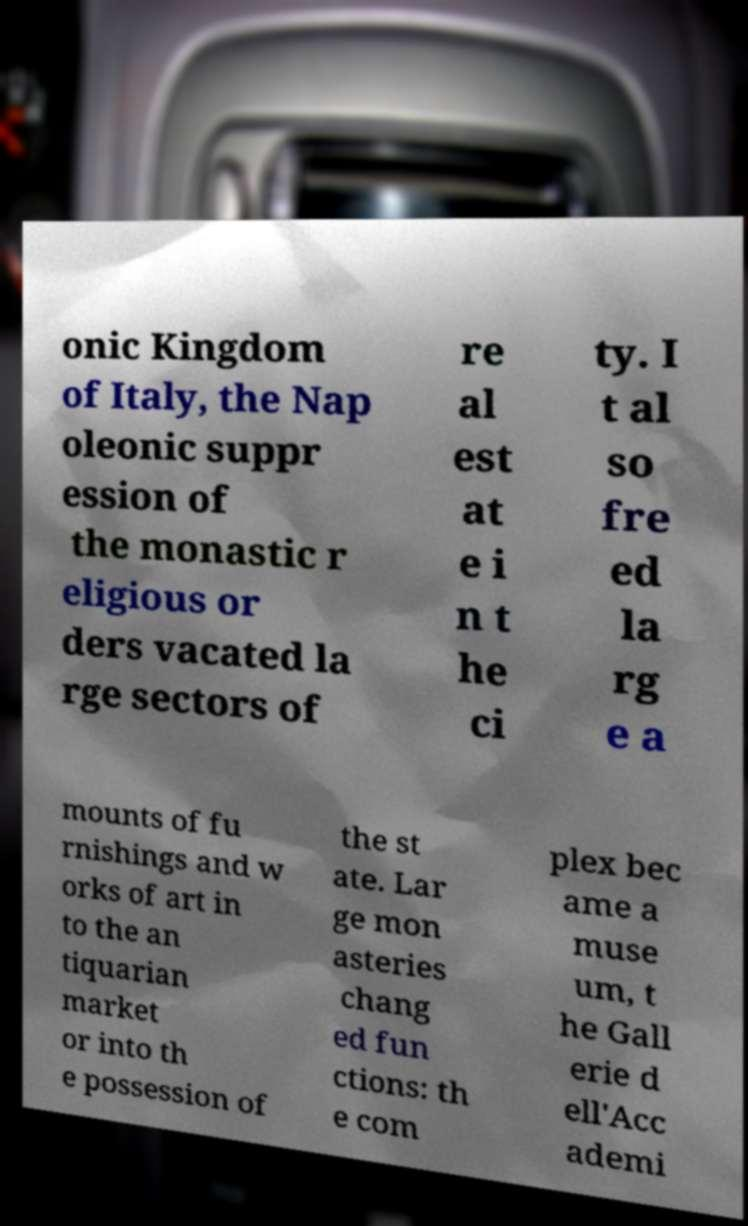There's text embedded in this image that I need extracted. Can you transcribe it verbatim? onic Kingdom of Italy, the Nap oleonic suppr ession of the monastic r eligious or ders vacated la rge sectors of re al est at e i n t he ci ty. I t al so fre ed la rg e a mounts of fu rnishings and w orks of art in to the an tiquarian market or into th e possession of the st ate. Lar ge mon asteries chang ed fun ctions: th e com plex bec ame a muse um, t he Gall erie d ell'Acc ademi 